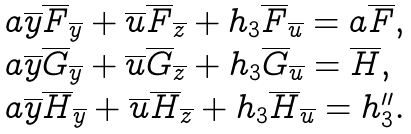Convert formula to latex. <formula><loc_0><loc_0><loc_500><loc_500>\begin{array} { l } a \overline { y } \overline { F } _ { \overline { y } } + \overline { u } \overline { F } _ { \overline { z } } + h _ { 3 } \overline { F } _ { \overline { u } } = a \overline { F } , \\ a \overline { y } \overline { G } _ { \overline { y } } + \overline { u } \overline { G } _ { \overline { z } } + h _ { 3 } \overline { G } _ { \overline { u } } = \overline { H } , \\ a \overline { y } \overline { H } _ { \overline { y } } + \overline { u } \overline { H } _ { \overline { z } } + h _ { 3 } \overline { H } _ { \overline { u } } = h _ { 3 } ^ { \prime \prime } . \end{array}</formula> 